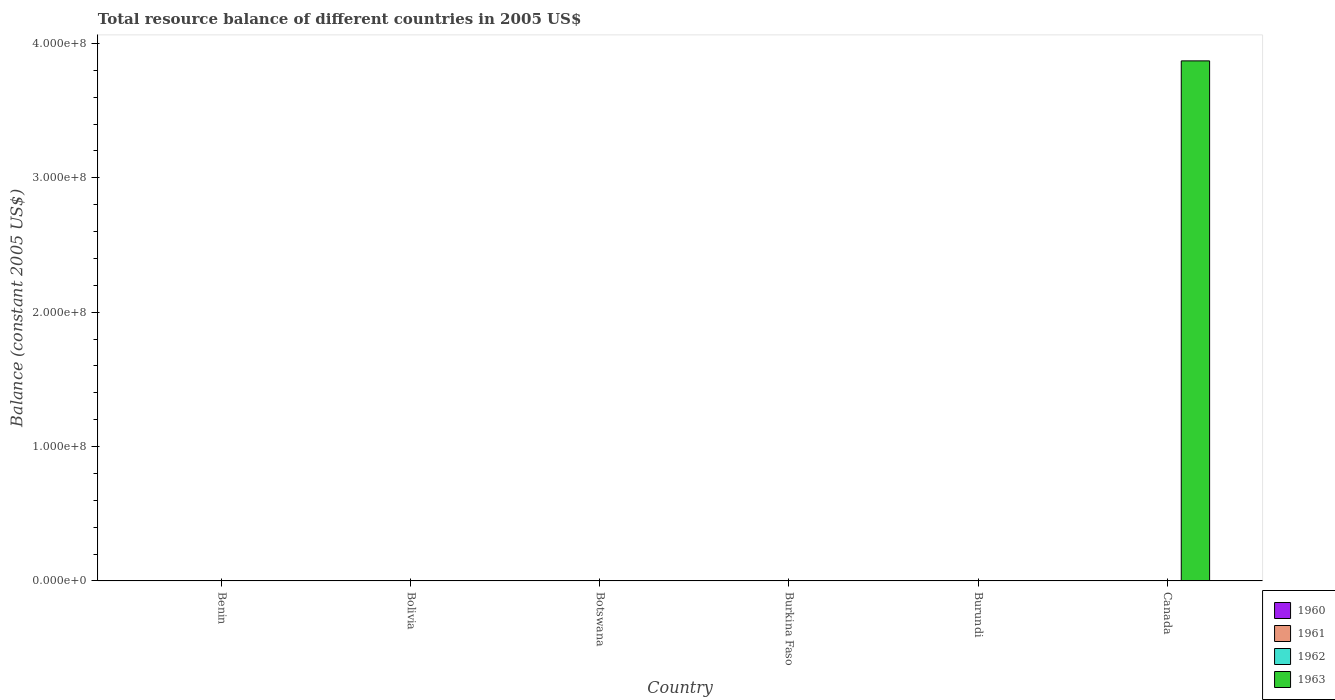Are the number of bars per tick equal to the number of legend labels?
Your answer should be very brief. No. How many bars are there on the 5th tick from the left?
Offer a terse response. 0. What is the label of the 1st group of bars from the left?
Give a very brief answer. Benin. What is the total resource balance in 1962 in Burundi?
Make the answer very short. 0. Across all countries, what is the maximum total resource balance in 1963?
Your answer should be very brief. 3.87e+08. Across all countries, what is the minimum total resource balance in 1963?
Provide a short and direct response. 0. What is the total total resource balance in 1963 in the graph?
Provide a succinct answer. 3.87e+08. What is the average total resource balance in 1962 per country?
Keep it short and to the point. 0. Is it the case that in every country, the sum of the total resource balance in 1963 and total resource balance in 1962 is greater than the total resource balance in 1960?
Make the answer very short. No. Are all the bars in the graph horizontal?
Offer a terse response. No. How many countries are there in the graph?
Give a very brief answer. 6. What is the difference between two consecutive major ticks on the Y-axis?
Offer a terse response. 1.00e+08. Are the values on the major ticks of Y-axis written in scientific E-notation?
Give a very brief answer. Yes. Does the graph contain any zero values?
Keep it short and to the point. Yes. Does the graph contain grids?
Make the answer very short. No. Where does the legend appear in the graph?
Provide a short and direct response. Bottom right. How many legend labels are there?
Your answer should be very brief. 4. How are the legend labels stacked?
Provide a short and direct response. Vertical. What is the title of the graph?
Provide a short and direct response. Total resource balance of different countries in 2005 US$. What is the label or title of the X-axis?
Provide a succinct answer. Country. What is the label or title of the Y-axis?
Give a very brief answer. Balance (constant 2005 US$). What is the Balance (constant 2005 US$) in 1960 in Benin?
Ensure brevity in your answer.  0. What is the Balance (constant 2005 US$) of 1961 in Benin?
Your answer should be very brief. 0. What is the Balance (constant 2005 US$) of 1962 in Benin?
Keep it short and to the point. 0. What is the Balance (constant 2005 US$) of 1961 in Bolivia?
Your answer should be compact. 0. What is the Balance (constant 2005 US$) in 1963 in Bolivia?
Your response must be concise. 0. What is the Balance (constant 2005 US$) of 1960 in Botswana?
Your answer should be very brief. 0. What is the Balance (constant 2005 US$) of 1962 in Botswana?
Offer a terse response. 0. What is the Balance (constant 2005 US$) in 1961 in Burkina Faso?
Your answer should be very brief. 0. What is the Balance (constant 2005 US$) in 1962 in Burkina Faso?
Offer a very short reply. 0. What is the Balance (constant 2005 US$) in 1960 in Burundi?
Give a very brief answer. 0. What is the Balance (constant 2005 US$) in 1961 in Burundi?
Make the answer very short. 0. What is the Balance (constant 2005 US$) in 1962 in Burundi?
Give a very brief answer. 0. What is the Balance (constant 2005 US$) of 1963 in Burundi?
Offer a terse response. 0. What is the Balance (constant 2005 US$) in 1960 in Canada?
Provide a short and direct response. 0. What is the Balance (constant 2005 US$) in 1961 in Canada?
Make the answer very short. 0. What is the Balance (constant 2005 US$) in 1962 in Canada?
Keep it short and to the point. 0. What is the Balance (constant 2005 US$) in 1963 in Canada?
Offer a terse response. 3.87e+08. Across all countries, what is the maximum Balance (constant 2005 US$) of 1963?
Your answer should be very brief. 3.87e+08. What is the total Balance (constant 2005 US$) of 1960 in the graph?
Provide a succinct answer. 0. What is the total Balance (constant 2005 US$) in 1961 in the graph?
Offer a very short reply. 0. What is the total Balance (constant 2005 US$) in 1962 in the graph?
Ensure brevity in your answer.  0. What is the total Balance (constant 2005 US$) of 1963 in the graph?
Offer a terse response. 3.87e+08. What is the average Balance (constant 2005 US$) in 1961 per country?
Offer a very short reply. 0. What is the average Balance (constant 2005 US$) in 1963 per country?
Your response must be concise. 6.45e+07. What is the difference between the highest and the lowest Balance (constant 2005 US$) of 1963?
Provide a short and direct response. 3.87e+08. 